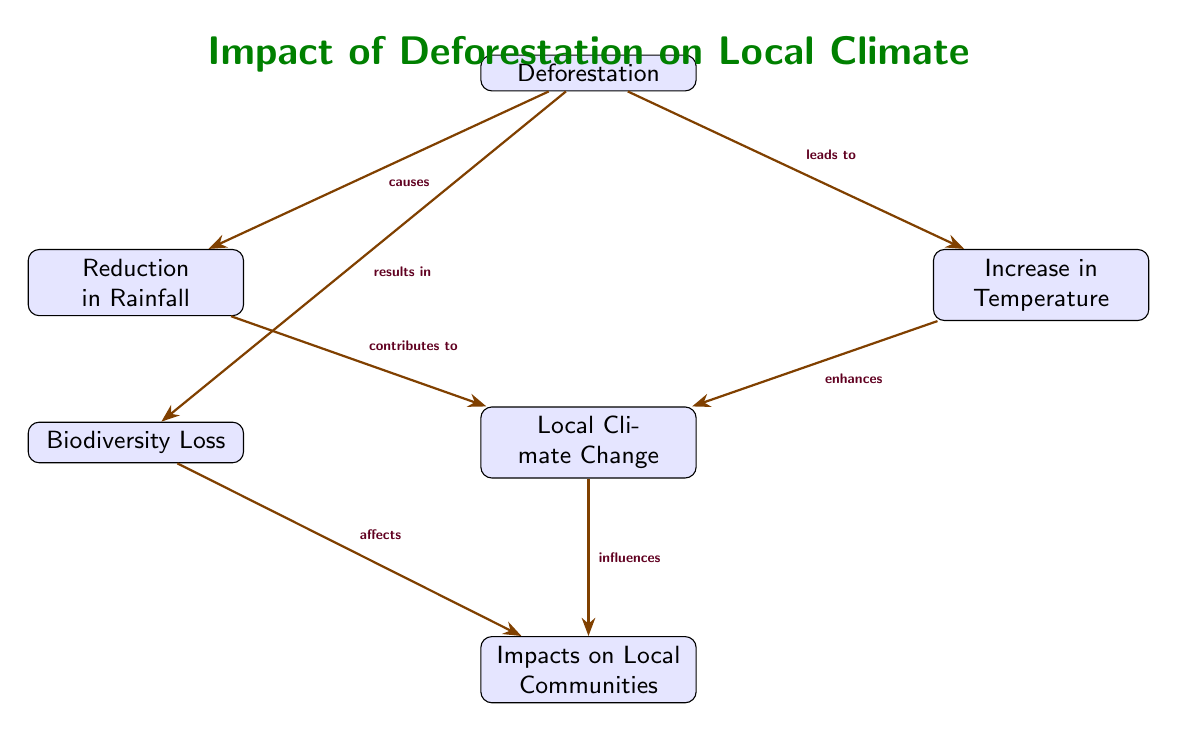What causes the reduction in rainfall? The diagram indicates that deforestation causes the reduction in rainfall, as shown by the directed arrow labeled "causes" pointing from deforestation to reduction in rainfall.
Answer: Deforestation What is the relationship between deforestation and biodiversity loss? The diagram shows that deforestation results in biodiversity loss, indicated by the arrow labeled "results in" connecting deforestation to biodiversity loss.
Answer: Results in How many impacts on local communities are identified in the diagram? There are two identified impacts on local communities: one stemming from biodiversity loss and one from local climate change, as represented by the arrows pointing to communities.
Answer: Two Which two factors contribute to local climate change? The factors contributing to local climate change are reduction in rainfall and increase in temperature, as evidenced by the arrows showing their connections to local climate change.
Answer: Reduction in rainfall and increase in temperature What happens to local communities as a result of biodiversity loss? The diagram notes that biodiversity loss affects local communities, as shown by the arrow labeled "affects" leading from biodiversity loss to communities.
Answer: Affects How does the increase in temperature impact local climate? The diagram illustrates that the increase in temperature enhances local climate, as represented by the arrow labeled "enhances" directed toward local climate change.
Answer: Enhances What is the first node listed in the diagram? The first node listed in the diagram is "Deforestation," as noted at the top of the diagram's structure.
Answer: Deforestation Explain the progression from deforestation to local climate change in the diagram. The progression begins with deforestation, which causes a reduction in rainfall and an increase in temperature. Both of these factors contribute to local climate change, as depicted by the arrows leading from reduction and increase to local climate.
Answer: Deforestation → Reduction in Rainfall, Increase in Temperature → Local Climate Change 